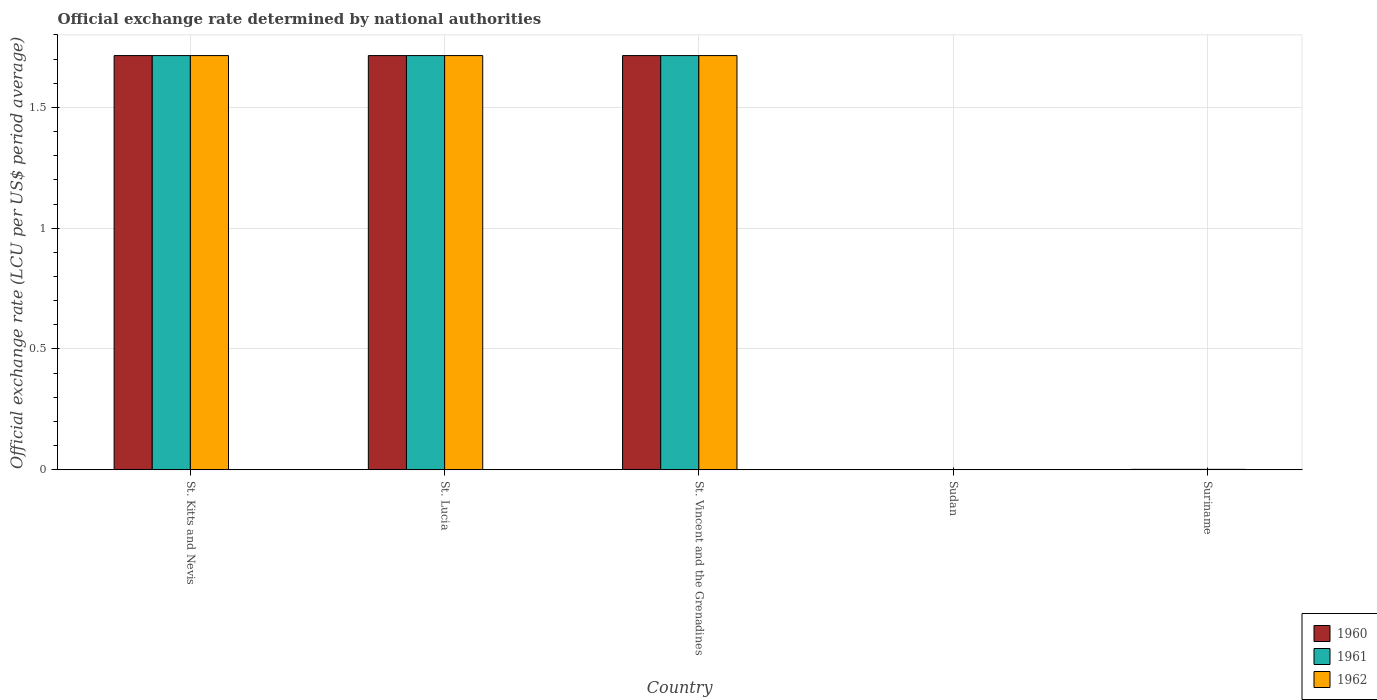How many different coloured bars are there?
Offer a terse response. 3. What is the label of the 3rd group of bars from the left?
Provide a short and direct response. St. Vincent and the Grenadines. What is the official exchange rate in 1962 in St. Lucia?
Your response must be concise. 1.71. Across all countries, what is the maximum official exchange rate in 1962?
Give a very brief answer. 1.71. Across all countries, what is the minimum official exchange rate in 1961?
Your response must be concise. 0. In which country was the official exchange rate in 1960 maximum?
Ensure brevity in your answer.  St. Kitts and Nevis. In which country was the official exchange rate in 1960 minimum?
Keep it short and to the point. Sudan. What is the total official exchange rate in 1962 in the graph?
Keep it short and to the point. 5.15. What is the difference between the official exchange rate in 1960 in Sudan and that in Suriname?
Make the answer very short. -0. What is the difference between the official exchange rate in 1960 in Sudan and the official exchange rate in 1961 in Suriname?
Your response must be concise. -0. What is the average official exchange rate in 1962 per country?
Make the answer very short. 1.03. What is the difference between the official exchange rate of/in 1962 and official exchange rate of/in 1961 in St. Kitts and Nevis?
Your response must be concise. 0. In how many countries, is the official exchange rate in 1961 greater than 0.5 LCU?
Your answer should be compact. 3. What is the ratio of the official exchange rate in 1961 in St. Kitts and Nevis to that in St. Vincent and the Grenadines?
Provide a succinct answer. 1. What is the difference between the highest and the lowest official exchange rate in 1961?
Keep it short and to the point. 1.71. Is the sum of the official exchange rate in 1961 in St. Lucia and Suriname greater than the maximum official exchange rate in 1960 across all countries?
Provide a succinct answer. Yes. What does the 1st bar from the right in St. Vincent and the Grenadines represents?
Your response must be concise. 1962. Is it the case that in every country, the sum of the official exchange rate in 1962 and official exchange rate in 1960 is greater than the official exchange rate in 1961?
Give a very brief answer. Yes. Are all the bars in the graph horizontal?
Ensure brevity in your answer.  No. What is the difference between two consecutive major ticks on the Y-axis?
Provide a short and direct response. 0.5. Does the graph contain any zero values?
Make the answer very short. No. How many legend labels are there?
Keep it short and to the point. 3. How are the legend labels stacked?
Offer a very short reply. Vertical. What is the title of the graph?
Give a very brief answer. Official exchange rate determined by national authorities. Does "1975" appear as one of the legend labels in the graph?
Ensure brevity in your answer.  No. What is the label or title of the X-axis?
Your answer should be compact. Country. What is the label or title of the Y-axis?
Offer a terse response. Official exchange rate (LCU per US$ period average). What is the Official exchange rate (LCU per US$ period average) of 1960 in St. Kitts and Nevis?
Your answer should be compact. 1.71. What is the Official exchange rate (LCU per US$ period average) in 1961 in St. Kitts and Nevis?
Offer a terse response. 1.71. What is the Official exchange rate (LCU per US$ period average) in 1962 in St. Kitts and Nevis?
Your answer should be compact. 1.71. What is the Official exchange rate (LCU per US$ period average) in 1960 in St. Lucia?
Your answer should be very brief. 1.71. What is the Official exchange rate (LCU per US$ period average) of 1961 in St. Lucia?
Offer a terse response. 1.71. What is the Official exchange rate (LCU per US$ period average) of 1962 in St. Lucia?
Offer a terse response. 1.71. What is the Official exchange rate (LCU per US$ period average) in 1960 in St. Vincent and the Grenadines?
Ensure brevity in your answer.  1.71. What is the Official exchange rate (LCU per US$ period average) of 1961 in St. Vincent and the Grenadines?
Give a very brief answer. 1.71. What is the Official exchange rate (LCU per US$ period average) in 1962 in St. Vincent and the Grenadines?
Provide a succinct answer. 1.71. What is the Official exchange rate (LCU per US$ period average) of 1960 in Sudan?
Offer a very short reply. 0. What is the Official exchange rate (LCU per US$ period average) of 1961 in Sudan?
Provide a succinct answer. 0. What is the Official exchange rate (LCU per US$ period average) of 1962 in Sudan?
Your answer should be very brief. 0. What is the Official exchange rate (LCU per US$ period average) in 1960 in Suriname?
Keep it short and to the point. 0. What is the Official exchange rate (LCU per US$ period average) of 1961 in Suriname?
Give a very brief answer. 0. What is the Official exchange rate (LCU per US$ period average) in 1962 in Suriname?
Offer a terse response. 0. Across all countries, what is the maximum Official exchange rate (LCU per US$ period average) of 1960?
Your answer should be compact. 1.71. Across all countries, what is the maximum Official exchange rate (LCU per US$ period average) in 1961?
Your response must be concise. 1.71. Across all countries, what is the maximum Official exchange rate (LCU per US$ period average) in 1962?
Your answer should be very brief. 1.71. Across all countries, what is the minimum Official exchange rate (LCU per US$ period average) of 1960?
Your answer should be very brief. 0. Across all countries, what is the minimum Official exchange rate (LCU per US$ period average) of 1961?
Give a very brief answer. 0. Across all countries, what is the minimum Official exchange rate (LCU per US$ period average) of 1962?
Offer a very short reply. 0. What is the total Official exchange rate (LCU per US$ period average) of 1960 in the graph?
Make the answer very short. 5.15. What is the total Official exchange rate (LCU per US$ period average) of 1961 in the graph?
Give a very brief answer. 5.15. What is the total Official exchange rate (LCU per US$ period average) in 1962 in the graph?
Keep it short and to the point. 5.15. What is the difference between the Official exchange rate (LCU per US$ period average) of 1960 in St. Kitts and Nevis and that in St. Lucia?
Your response must be concise. 0. What is the difference between the Official exchange rate (LCU per US$ period average) in 1962 in St. Kitts and Nevis and that in St. Lucia?
Ensure brevity in your answer.  0. What is the difference between the Official exchange rate (LCU per US$ period average) in 1961 in St. Kitts and Nevis and that in St. Vincent and the Grenadines?
Provide a succinct answer. 0. What is the difference between the Official exchange rate (LCU per US$ period average) of 1962 in St. Kitts and Nevis and that in St. Vincent and the Grenadines?
Your answer should be compact. 0. What is the difference between the Official exchange rate (LCU per US$ period average) of 1960 in St. Kitts and Nevis and that in Sudan?
Provide a short and direct response. 1.71. What is the difference between the Official exchange rate (LCU per US$ period average) in 1961 in St. Kitts and Nevis and that in Sudan?
Offer a terse response. 1.71. What is the difference between the Official exchange rate (LCU per US$ period average) of 1962 in St. Kitts and Nevis and that in Sudan?
Provide a short and direct response. 1.71. What is the difference between the Official exchange rate (LCU per US$ period average) of 1960 in St. Kitts and Nevis and that in Suriname?
Offer a terse response. 1.71. What is the difference between the Official exchange rate (LCU per US$ period average) in 1961 in St. Kitts and Nevis and that in Suriname?
Provide a succinct answer. 1.71. What is the difference between the Official exchange rate (LCU per US$ period average) of 1962 in St. Kitts and Nevis and that in Suriname?
Provide a succinct answer. 1.71. What is the difference between the Official exchange rate (LCU per US$ period average) of 1961 in St. Lucia and that in St. Vincent and the Grenadines?
Offer a very short reply. 0. What is the difference between the Official exchange rate (LCU per US$ period average) of 1960 in St. Lucia and that in Sudan?
Give a very brief answer. 1.71. What is the difference between the Official exchange rate (LCU per US$ period average) of 1961 in St. Lucia and that in Sudan?
Keep it short and to the point. 1.71. What is the difference between the Official exchange rate (LCU per US$ period average) of 1962 in St. Lucia and that in Sudan?
Offer a very short reply. 1.71. What is the difference between the Official exchange rate (LCU per US$ period average) in 1960 in St. Lucia and that in Suriname?
Provide a succinct answer. 1.71. What is the difference between the Official exchange rate (LCU per US$ period average) in 1961 in St. Lucia and that in Suriname?
Give a very brief answer. 1.71. What is the difference between the Official exchange rate (LCU per US$ period average) of 1962 in St. Lucia and that in Suriname?
Offer a very short reply. 1.71. What is the difference between the Official exchange rate (LCU per US$ period average) of 1960 in St. Vincent and the Grenadines and that in Sudan?
Offer a very short reply. 1.71. What is the difference between the Official exchange rate (LCU per US$ period average) of 1961 in St. Vincent and the Grenadines and that in Sudan?
Give a very brief answer. 1.71. What is the difference between the Official exchange rate (LCU per US$ period average) of 1962 in St. Vincent and the Grenadines and that in Sudan?
Keep it short and to the point. 1.71. What is the difference between the Official exchange rate (LCU per US$ period average) of 1960 in St. Vincent and the Grenadines and that in Suriname?
Your answer should be very brief. 1.71. What is the difference between the Official exchange rate (LCU per US$ period average) in 1961 in St. Vincent and the Grenadines and that in Suriname?
Provide a short and direct response. 1.71. What is the difference between the Official exchange rate (LCU per US$ period average) in 1962 in St. Vincent and the Grenadines and that in Suriname?
Offer a very short reply. 1.71. What is the difference between the Official exchange rate (LCU per US$ period average) in 1960 in Sudan and that in Suriname?
Offer a terse response. -0. What is the difference between the Official exchange rate (LCU per US$ period average) in 1961 in Sudan and that in Suriname?
Give a very brief answer. -0. What is the difference between the Official exchange rate (LCU per US$ period average) in 1962 in Sudan and that in Suriname?
Offer a terse response. -0. What is the difference between the Official exchange rate (LCU per US$ period average) in 1960 in St. Kitts and Nevis and the Official exchange rate (LCU per US$ period average) in 1961 in St. Lucia?
Your answer should be very brief. 0. What is the difference between the Official exchange rate (LCU per US$ period average) in 1960 in St. Kitts and Nevis and the Official exchange rate (LCU per US$ period average) in 1961 in St. Vincent and the Grenadines?
Ensure brevity in your answer.  0. What is the difference between the Official exchange rate (LCU per US$ period average) of 1960 in St. Kitts and Nevis and the Official exchange rate (LCU per US$ period average) of 1962 in St. Vincent and the Grenadines?
Keep it short and to the point. 0. What is the difference between the Official exchange rate (LCU per US$ period average) in 1961 in St. Kitts and Nevis and the Official exchange rate (LCU per US$ period average) in 1962 in St. Vincent and the Grenadines?
Make the answer very short. 0. What is the difference between the Official exchange rate (LCU per US$ period average) in 1960 in St. Kitts and Nevis and the Official exchange rate (LCU per US$ period average) in 1961 in Sudan?
Ensure brevity in your answer.  1.71. What is the difference between the Official exchange rate (LCU per US$ period average) of 1960 in St. Kitts and Nevis and the Official exchange rate (LCU per US$ period average) of 1962 in Sudan?
Your answer should be very brief. 1.71. What is the difference between the Official exchange rate (LCU per US$ period average) in 1961 in St. Kitts and Nevis and the Official exchange rate (LCU per US$ period average) in 1962 in Sudan?
Your response must be concise. 1.71. What is the difference between the Official exchange rate (LCU per US$ period average) in 1960 in St. Kitts and Nevis and the Official exchange rate (LCU per US$ period average) in 1961 in Suriname?
Offer a very short reply. 1.71. What is the difference between the Official exchange rate (LCU per US$ period average) of 1960 in St. Kitts and Nevis and the Official exchange rate (LCU per US$ period average) of 1962 in Suriname?
Your response must be concise. 1.71. What is the difference between the Official exchange rate (LCU per US$ period average) of 1961 in St. Kitts and Nevis and the Official exchange rate (LCU per US$ period average) of 1962 in Suriname?
Keep it short and to the point. 1.71. What is the difference between the Official exchange rate (LCU per US$ period average) in 1960 in St. Lucia and the Official exchange rate (LCU per US$ period average) in 1961 in Sudan?
Keep it short and to the point. 1.71. What is the difference between the Official exchange rate (LCU per US$ period average) in 1960 in St. Lucia and the Official exchange rate (LCU per US$ period average) in 1962 in Sudan?
Make the answer very short. 1.71. What is the difference between the Official exchange rate (LCU per US$ period average) of 1961 in St. Lucia and the Official exchange rate (LCU per US$ period average) of 1962 in Sudan?
Offer a terse response. 1.71. What is the difference between the Official exchange rate (LCU per US$ period average) of 1960 in St. Lucia and the Official exchange rate (LCU per US$ period average) of 1961 in Suriname?
Provide a succinct answer. 1.71. What is the difference between the Official exchange rate (LCU per US$ period average) in 1960 in St. Lucia and the Official exchange rate (LCU per US$ period average) in 1962 in Suriname?
Your answer should be compact. 1.71. What is the difference between the Official exchange rate (LCU per US$ period average) of 1961 in St. Lucia and the Official exchange rate (LCU per US$ period average) of 1962 in Suriname?
Your answer should be very brief. 1.71. What is the difference between the Official exchange rate (LCU per US$ period average) of 1960 in St. Vincent and the Grenadines and the Official exchange rate (LCU per US$ period average) of 1961 in Sudan?
Make the answer very short. 1.71. What is the difference between the Official exchange rate (LCU per US$ period average) in 1960 in St. Vincent and the Grenadines and the Official exchange rate (LCU per US$ period average) in 1962 in Sudan?
Your response must be concise. 1.71. What is the difference between the Official exchange rate (LCU per US$ period average) in 1961 in St. Vincent and the Grenadines and the Official exchange rate (LCU per US$ period average) in 1962 in Sudan?
Ensure brevity in your answer.  1.71. What is the difference between the Official exchange rate (LCU per US$ period average) in 1960 in St. Vincent and the Grenadines and the Official exchange rate (LCU per US$ period average) in 1961 in Suriname?
Your answer should be very brief. 1.71. What is the difference between the Official exchange rate (LCU per US$ period average) in 1960 in St. Vincent and the Grenadines and the Official exchange rate (LCU per US$ period average) in 1962 in Suriname?
Offer a terse response. 1.71. What is the difference between the Official exchange rate (LCU per US$ period average) in 1961 in St. Vincent and the Grenadines and the Official exchange rate (LCU per US$ period average) in 1962 in Suriname?
Offer a terse response. 1.71. What is the difference between the Official exchange rate (LCU per US$ period average) of 1960 in Sudan and the Official exchange rate (LCU per US$ period average) of 1961 in Suriname?
Offer a terse response. -0. What is the difference between the Official exchange rate (LCU per US$ period average) in 1960 in Sudan and the Official exchange rate (LCU per US$ period average) in 1962 in Suriname?
Make the answer very short. -0. What is the difference between the Official exchange rate (LCU per US$ period average) of 1961 in Sudan and the Official exchange rate (LCU per US$ period average) of 1962 in Suriname?
Offer a very short reply. -0. What is the average Official exchange rate (LCU per US$ period average) in 1960 per country?
Ensure brevity in your answer.  1.03. What is the difference between the Official exchange rate (LCU per US$ period average) of 1961 and Official exchange rate (LCU per US$ period average) of 1962 in St. Kitts and Nevis?
Offer a terse response. 0. What is the difference between the Official exchange rate (LCU per US$ period average) of 1960 and Official exchange rate (LCU per US$ period average) of 1961 in St. Lucia?
Provide a short and direct response. 0. What is the difference between the Official exchange rate (LCU per US$ period average) of 1960 and Official exchange rate (LCU per US$ period average) of 1962 in St. Vincent and the Grenadines?
Offer a very short reply. 0. What is the difference between the Official exchange rate (LCU per US$ period average) in 1960 and Official exchange rate (LCU per US$ period average) in 1961 in Sudan?
Your answer should be compact. 0. What is the difference between the Official exchange rate (LCU per US$ period average) of 1961 and Official exchange rate (LCU per US$ period average) of 1962 in Sudan?
Your answer should be compact. 0. What is the difference between the Official exchange rate (LCU per US$ period average) in 1960 and Official exchange rate (LCU per US$ period average) in 1961 in Suriname?
Your response must be concise. 0. What is the difference between the Official exchange rate (LCU per US$ period average) in 1960 and Official exchange rate (LCU per US$ period average) in 1962 in Suriname?
Provide a short and direct response. 0. What is the difference between the Official exchange rate (LCU per US$ period average) in 1961 and Official exchange rate (LCU per US$ period average) in 1962 in Suriname?
Keep it short and to the point. 0. What is the ratio of the Official exchange rate (LCU per US$ period average) of 1960 in St. Kitts and Nevis to that in St. Lucia?
Your answer should be compact. 1. What is the ratio of the Official exchange rate (LCU per US$ period average) of 1962 in St. Kitts and Nevis to that in St. Lucia?
Offer a terse response. 1. What is the ratio of the Official exchange rate (LCU per US$ period average) of 1960 in St. Kitts and Nevis to that in St. Vincent and the Grenadines?
Your answer should be compact. 1. What is the ratio of the Official exchange rate (LCU per US$ period average) of 1962 in St. Kitts and Nevis to that in St. Vincent and the Grenadines?
Ensure brevity in your answer.  1. What is the ratio of the Official exchange rate (LCU per US$ period average) in 1960 in St. Kitts and Nevis to that in Sudan?
Your response must be concise. 4923.29. What is the ratio of the Official exchange rate (LCU per US$ period average) in 1961 in St. Kitts and Nevis to that in Sudan?
Your answer should be very brief. 4923.29. What is the ratio of the Official exchange rate (LCU per US$ period average) in 1962 in St. Kitts and Nevis to that in Sudan?
Provide a succinct answer. 4923.29. What is the ratio of the Official exchange rate (LCU per US$ period average) in 1960 in St. Kitts and Nevis to that in Suriname?
Offer a very short reply. 909.44. What is the ratio of the Official exchange rate (LCU per US$ period average) in 1961 in St. Kitts and Nevis to that in Suriname?
Your answer should be very brief. 909.44. What is the ratio of the Official exchange rate (LCU per US$ period average) of 1962 in St. Kitts and Nevis to that in Suriname?
Your answer should be very brief. 909.44. What is the ratio of the Official exchange rate (LCU per US$ period average) of 1960 in St. Lucia to that in St. Vincent and the Grenadines?
Provide a succinct answer. 1. What is the ratio of the Official exchange rate (LCU per US$ period average) in 1961 in St. Lucia to that in St. Vincent and the Grenadines?
Ensure brevity in your answer.  1. What is the ratio of the Official exchange rate (LCU per US$ period average) in 1962 in St. Lucia to that in St. Vincent and the Grenadines?
Your answer should be very brief. 1. What is the ratio of the Official exchange rate (LCU per US$ period average) of 1960 in St. Lucia to that in Sudan?
Ensure brevity in your answer.  4923.29. What is the ratio of the Official exchange rate (LCU per US$ period average) of 1961 in St. Lucia to that in Sudan?
Offer a very short reply. 4923.29. What is the ratio of the Official exchange rate (LCU per US$ period average) of 1962 in St. Lucia to that in Sudan?
Make the answer very short. 4923.29. What is the ratio of the Official exchange rate (LCU per US$ period average) of 1960 in St. Lucia to that in Suriname?
Provide a succinct answer. 909.44. What is the ratio of the Official exchange rate (LCU per US$ period average) of 1961 in St. Lucia to that in Suriname?
Your answer should be very brief. 909.44. What is the ratio of the Official exchange rate (LCU per US$ period average) in 1962 in St. Lucia to that in Suriname?
Ensure brevity in your answer.  909.44. What is the ratio of the Official exchange rate (LCU per US$ period average) of 1960 in St. Vincent and the Grenadines to that in Sudan?
Keep it short and to the point. 4923.29. What is the ratio of the Official exchange rate (LCU per US$ period average) in 1961 in St. Vincent and the Grenadines to that in Sudan?
Offer a very short reply. 4923.29. What is the ratio of the Official exchange rate (LCU per US$ period average) in 1962 in St. Vincent and the Grenadines to that in Sudan?
Ensure brevity in your answer.  4923.29. What is the ratio of the Official exchange rate (LCU per US$ period average) of 1960 in St. Vincent and the Grenadines to that in Suriname?
Your answer should be compact. 909.44. What is the ratio of the Official exchange rate (LCU per US$ period average) of 1961 in St. Vincent and the Grenadines to that in Suriname?
Ensure brevity in your answer.  909.44. What is the ratio of the Official exchange rate (LCU per US$ period average) of 1962 in St. Vincent and the Grenadines to that in Suriname?
Provide a succinct answer. 909.44. What is the ratio of the Official exchange rate (LCU per US$ period average) in 1960 in Sudan to that in Suriname?
Provide a succinct answer. 0.18. What is the ratio of the Official exchange rate (LCU per US$ period average) in 1961 in Sudan to that in Suriname?
Your answer should be compact. 0.18. What is the ratio of the Official exchange rate (LCU per US$ period average) of 1962 in Sudan to that in Suriname?
Ensure brevity in your answer.  0.18. What is the difference between the highest and the second highest Official exchange rate (LCU per US$ period average) of 1960?
Offer a terse response. 0. What is the difference between the highest and the lowest Official exchange rate (LCU per US$ period average) in 1960?
Your answer should be very brief. 1.71. What is the difference between the highest and the lowest Official exchange rate (LCU per US$ period average) in 1961?
Your response must be concise. 1.71. What is the difference between the highest and the lowest Official exchange rate (LCU per US$ period average) of 1962?
Give a very brief answer. 1.71. 